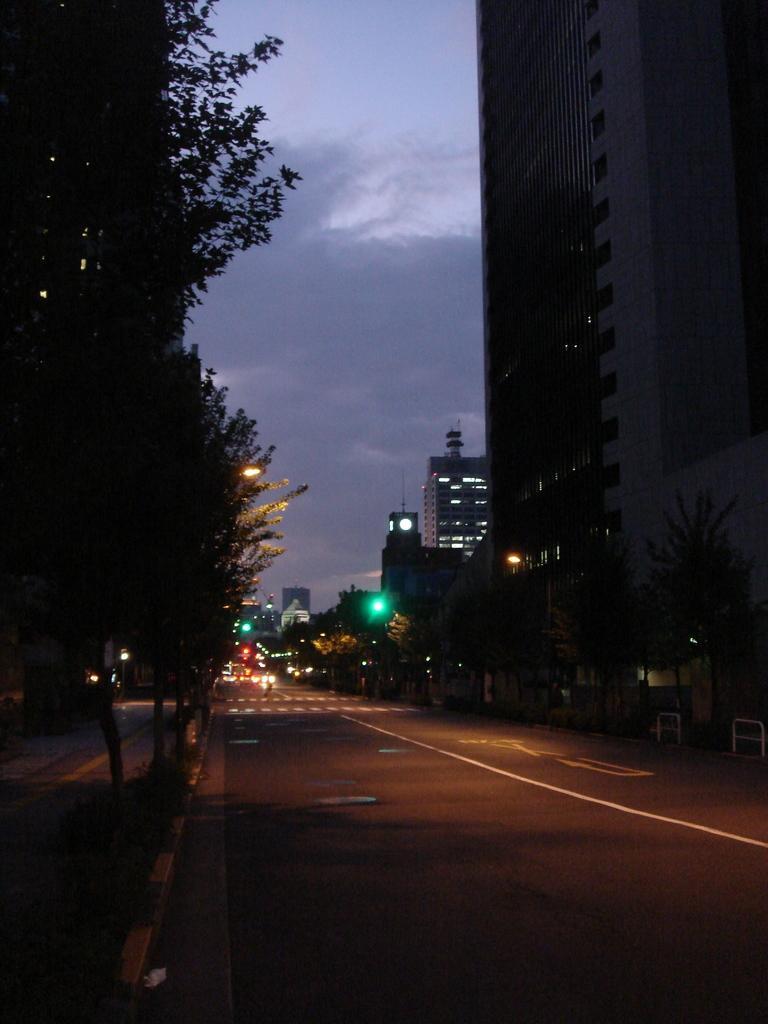Describe this image in one or two sentences. In the foreground I can see the road. There are trees on the left side and the right side as well. I can see the buildings on the right side. In the background, I can see the vehicles on the road. There are clouds in the sky. 